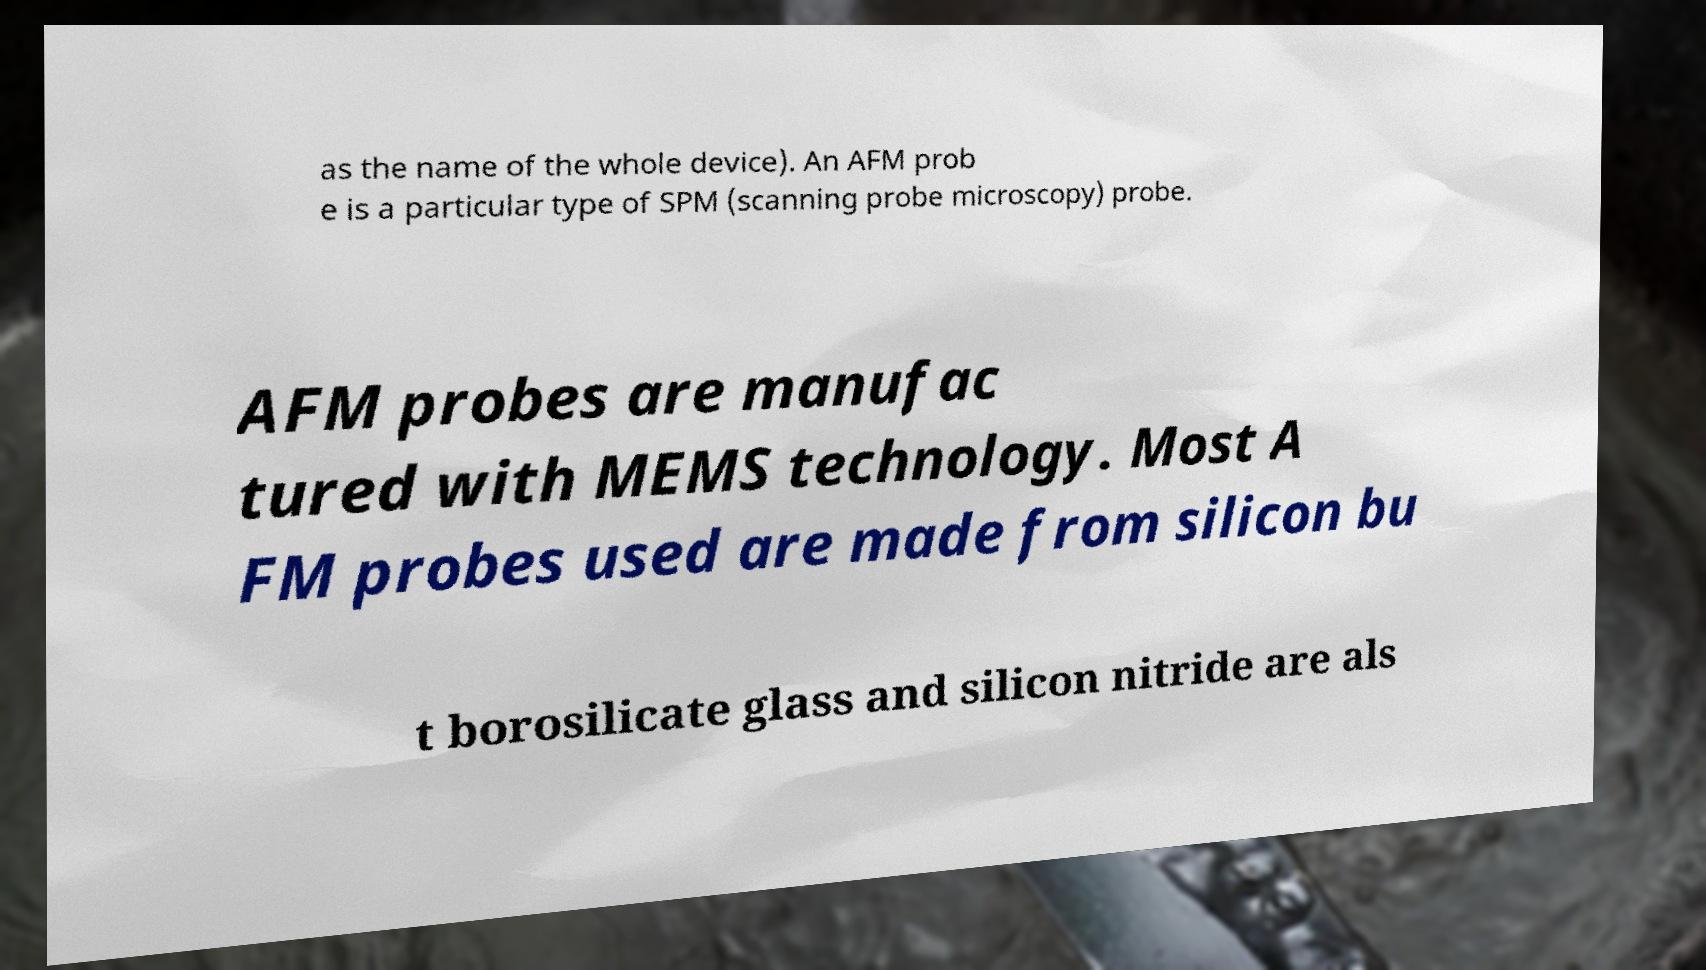Could you extract and type out the text from this image? as the name of the whole device). An AFM prob e is a particular type of SPM (scanning probe microscopy) probe. AFM probes are manufac tured with MEMS technology. Most A FM probes used are made from silicon bu t borosilicate glass and silicon nitride are als 